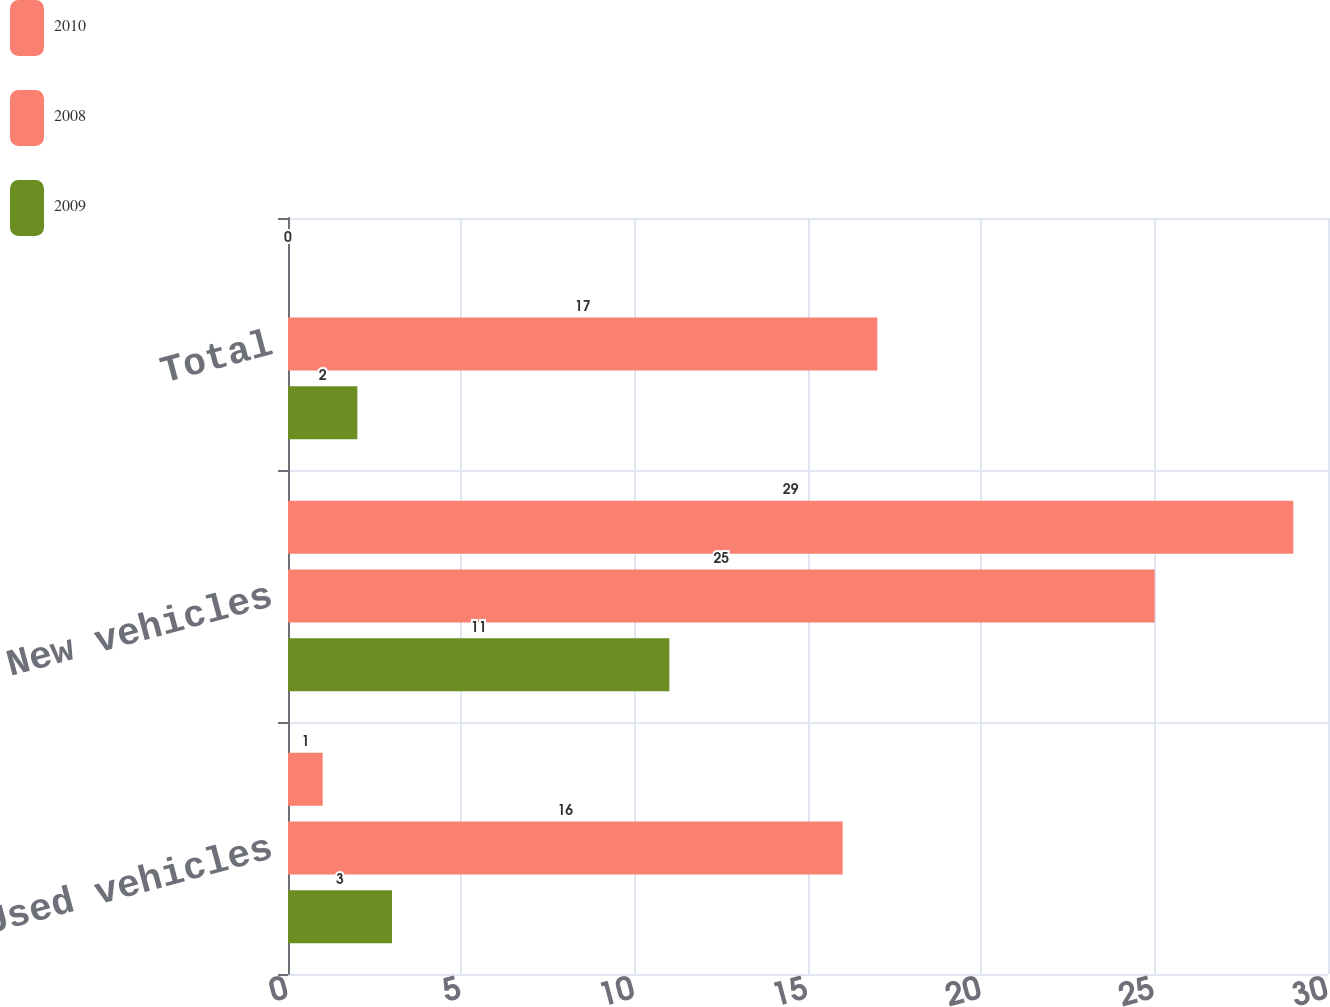<chart> <loc_0><loc_0><loc_500><loc_500><stacked_bar_chart><ecel><fcel>Used vehicles<fcel>New vehicles<fcel>Total<nl><fcel>2010<fcel>1<fcel>29<fcel>0<nl><fcel>2008<fcel>16<fcel>25<fcel>17<nl><fcel>2009<fcel>3<fcel>11<fcel>2<nl></chart> 